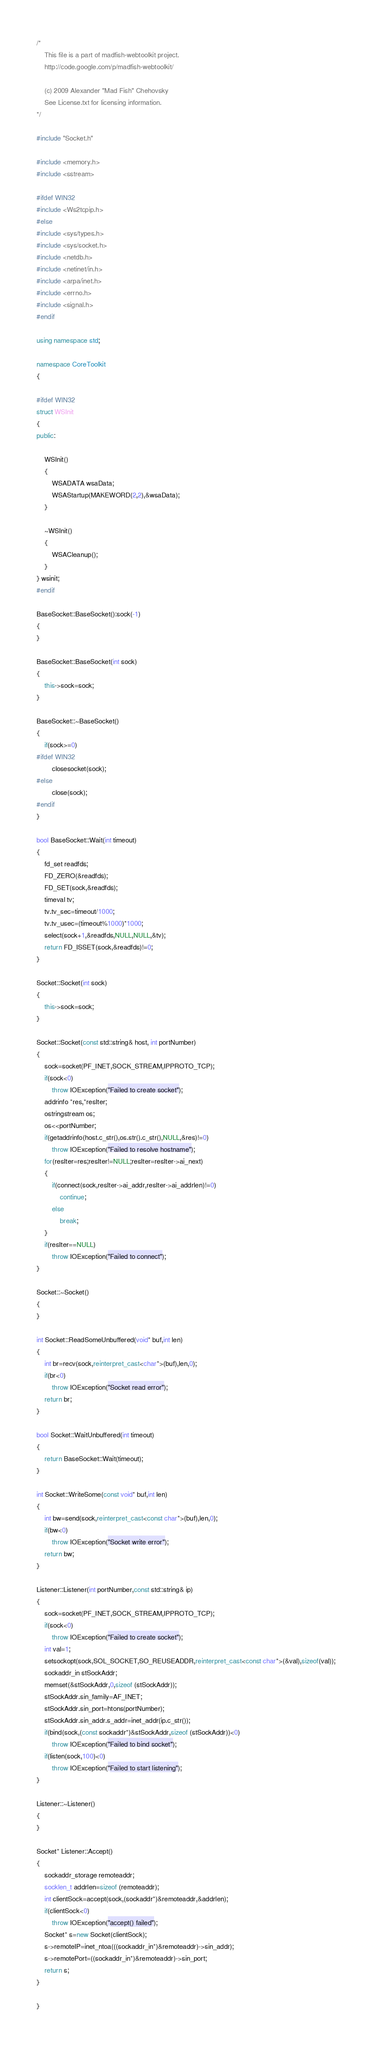<code> <loc_0><loc_0><loc_500><loc_500><_C++_>/*
	This file is a part of madfish-webtoolkit project.
	http://code.google.com/p/madfish-webtoolkit/

	(c) 2009 Alexander "Mad Fish" Chehovsky
	See License.txt for licensing information.
*/

#include "Socket.h"

#include <memory.h>
#include <sstream>

#ifdef WIN32
#include <Ws2tcpip.h>
#else
#include <sys/types.h>
#include <sys/socket.h>
#include <netdb.h>
#include <netinet/in.h>
#include <arpa/inet.h>
#include <errno.h>
#include <signal.h>
#endif

using namespace std;

namespace CoreToolkit
{

#ifdef WIN32
struct WSInit
{
public:

	WSInit()
	{
		WSADATA wsaData;
		WSAStartup(MAKEWORD(2,2),&wsaData);
	}

	~WSInit()
	{
		WSACleanup();
	}
} wsinit;
#endif

BaseSocket::BaseSocket():sock(-1)
{
}

BaseSocket::BaseSocket(int sock)
{
	this->sock=sock;
}

BaseSocket::~BaseSocket()
{
	if(sock>=0)
#ifdef WIN32
		closesocket(sock);
#else
		close(sock);
#endif
}

bool BaseSocket::Wait(int timeout)
{
	fd_set readfds;
	FD_ZERO(&readfds);
	FD_SET(sock,&readfds);
	timeval tv;
	tv.tv_sec=timeout/1000;
	tv.tv_usec=(timeout%1000)*1000;
	select(sock+1,&readfds,NULL,NULL,&tv);
	return FD_ISSET(sock,&readfds)!=0;
}

Socket::Socket(int sock)
{
	this->sock=sock;
}

Socket::Socket(const std::string& host, int portNumber)
{
	sock=socket(PF_INET,SOCK_STREAM,IPPROTO_TCP);
	if(sock<0)
		throw IOException("Failed to create socket");
	addrinfo *res,*resIter;
	ostringstream os;
	os<<portNumber;
	if(getaddrinfo(host.c_str(),os.str().c_str(),NULL,&res)!=0)
		throw IOException("Failed to resolve hostname");
	for(resIter=res;resIter!=NULL;resIter=resIter->ai_next)
	{
		if(connect(sock,resIter->ai_addr,resIter->ai_addrlen)!=0)
			continue;
		else
			break;
	}
	if(resIter==NULL)
		throw IOException("Failed to connect");
}

Socket::~Socket()
{
}

int Socket::ReadSomeUnbuffered(void* buf,int len)
{
	int br=recv(sock,reinterpret_cast<char*>(buf),len,0);
	if(br<0)
		throw IOException("Socket read error");
	return br;
}

bool Socket::WaitUnbuffered(int timeout)
{
	return BaseSocket::Wait(timeout);
}

int Socket::WriteSome(const void* buf,int len)
{
	int bw=send(sock,reinterpret_cast<const char*>(buf),len,0);
	if(bw<0)
		throw IOException("Socket write error");
	return bw;
}

Listener::Listener(int portNumber,const std::string& ip)
{
	sock=socket(PF_INET,SOCK_STREAM,IPPROTO_TCP);
	if(sock<0)
		throw IOException("Failed to create socket");
	int val=1;
	setsockopt(sock,SOL_SOCKET,SO_REUSEADDR,reinterpret_cast<const char*>(&val),sizeof(val));
	sockaddr_in stSockAddr;
	memset(&stSockAddr,0,sizeof (stSockAddr));
	stSockAddr.sin_family=AF_INET;
	stSockAddr.sin_port=htons(portNumber);
	stSockAddr.sin_addr.s_addr=inet_addr(ip.c_str());
	if(bind(sock,(const sockaddr*)&stSockAddr,sizeof (stSockAddr))<0)
		throw IOException("Failed to bind socket");
	if(listen(sock,100)<0)
		throw IOException("Failed to start listening");
}

Listener::~Listener()
{
}

Socket* Listener::Accept()
{
	sockaddr_storage remoteaddr;
	socklen_t addrlen=sizeof (remoteaddr);
	int clientSock=accept(sock,(sockaddr*)&remoteaddr,&addrlen);
	if(clientSock<0)
		throw IOException("accept() failed");
	Socket* s=new Socket(clientSock);
	s->remoteIP=inet_ntoa(((sockaddr_in*)&remoteaddr)->sin_addr);
	s->remotePort=((sockaddr_in*)&remoteaddr)->sin_port;
	return s;
}

}
</code> 